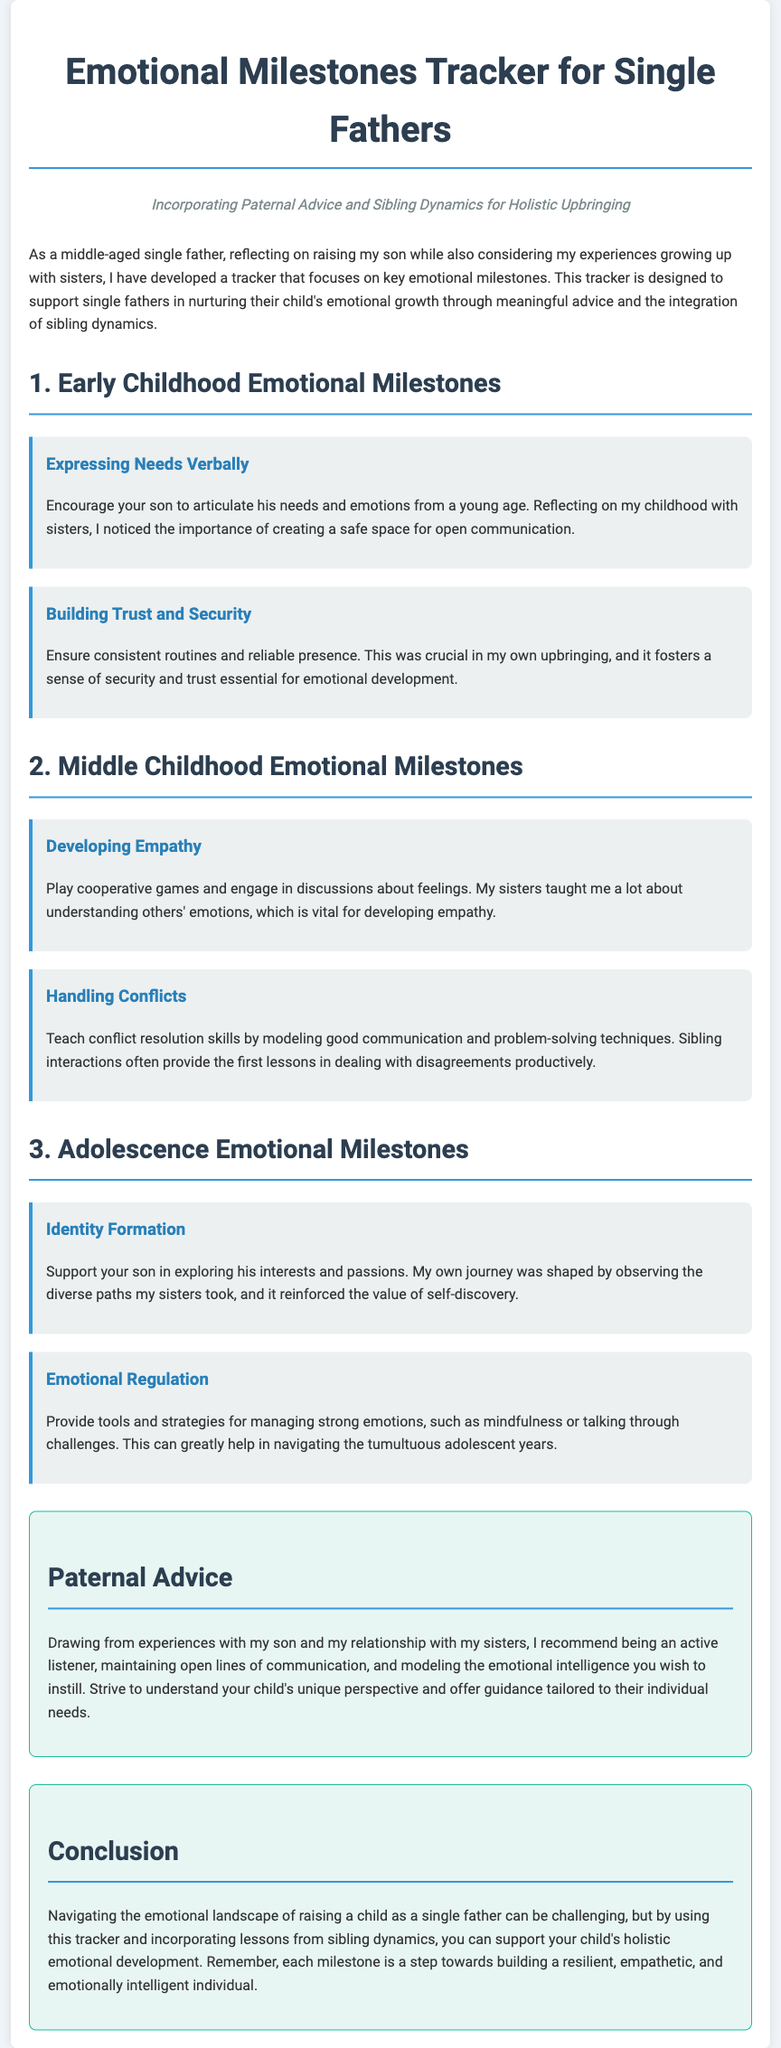What is the title of the document? The title appears at the top of the document and clearly states the focus of the content.
Answer: Emotional Milestones Tracker for Single Fathers What are the three emotional milestone phases mentioned? The phases are listed under each section heading, indicating the focus of emotional development for specific age ranges.
Answer: Early Childhood, Middle Childhood, Adolescence What is suggested to encourage in Early Childhood emotional milestones? This is found in the milestones section, addressing specific behaviors to nurture.
Answer: Expressing Needs Verbally Which milestone emphasizes trust and security? This is specifically stated in the Early Childhood section as a critical aspect of emotional development.
Answer: Building Trust and Security What activity is recommended for developing empathy? This is found in the Middle Childhood emotional milestones section and suggests specific interactions to foster understanding.
Answer: Play cooperative games How does the document suggest handling conflicts? The document outlines specific skills to be taught and modeled for effective resolution.
Answer: Teach conflict resolution skills What is one piece of paternal advice given in the document? This is found in the dedicated advice section, summarizing key guidance for fathers.
Answer: Be an active listener Which sibling dynamics are highlighted as beneficial? This refers to the shared experiences highlighted throughout the document, particularly in relation to emotional understanding.
Answer: Understanding others' emotions In the conclusion, what does the tracker support? The conclusion summarizes the overarching benefit of using the tracker as mentioned towards the end of the document.
Answer: Holistic emotional development 